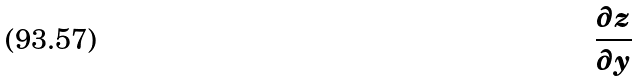Convert formula to latex. <formula><loc_0><loc_0><loc_500><loc_500>\frac { \partial z } { \partial y }</formula> 